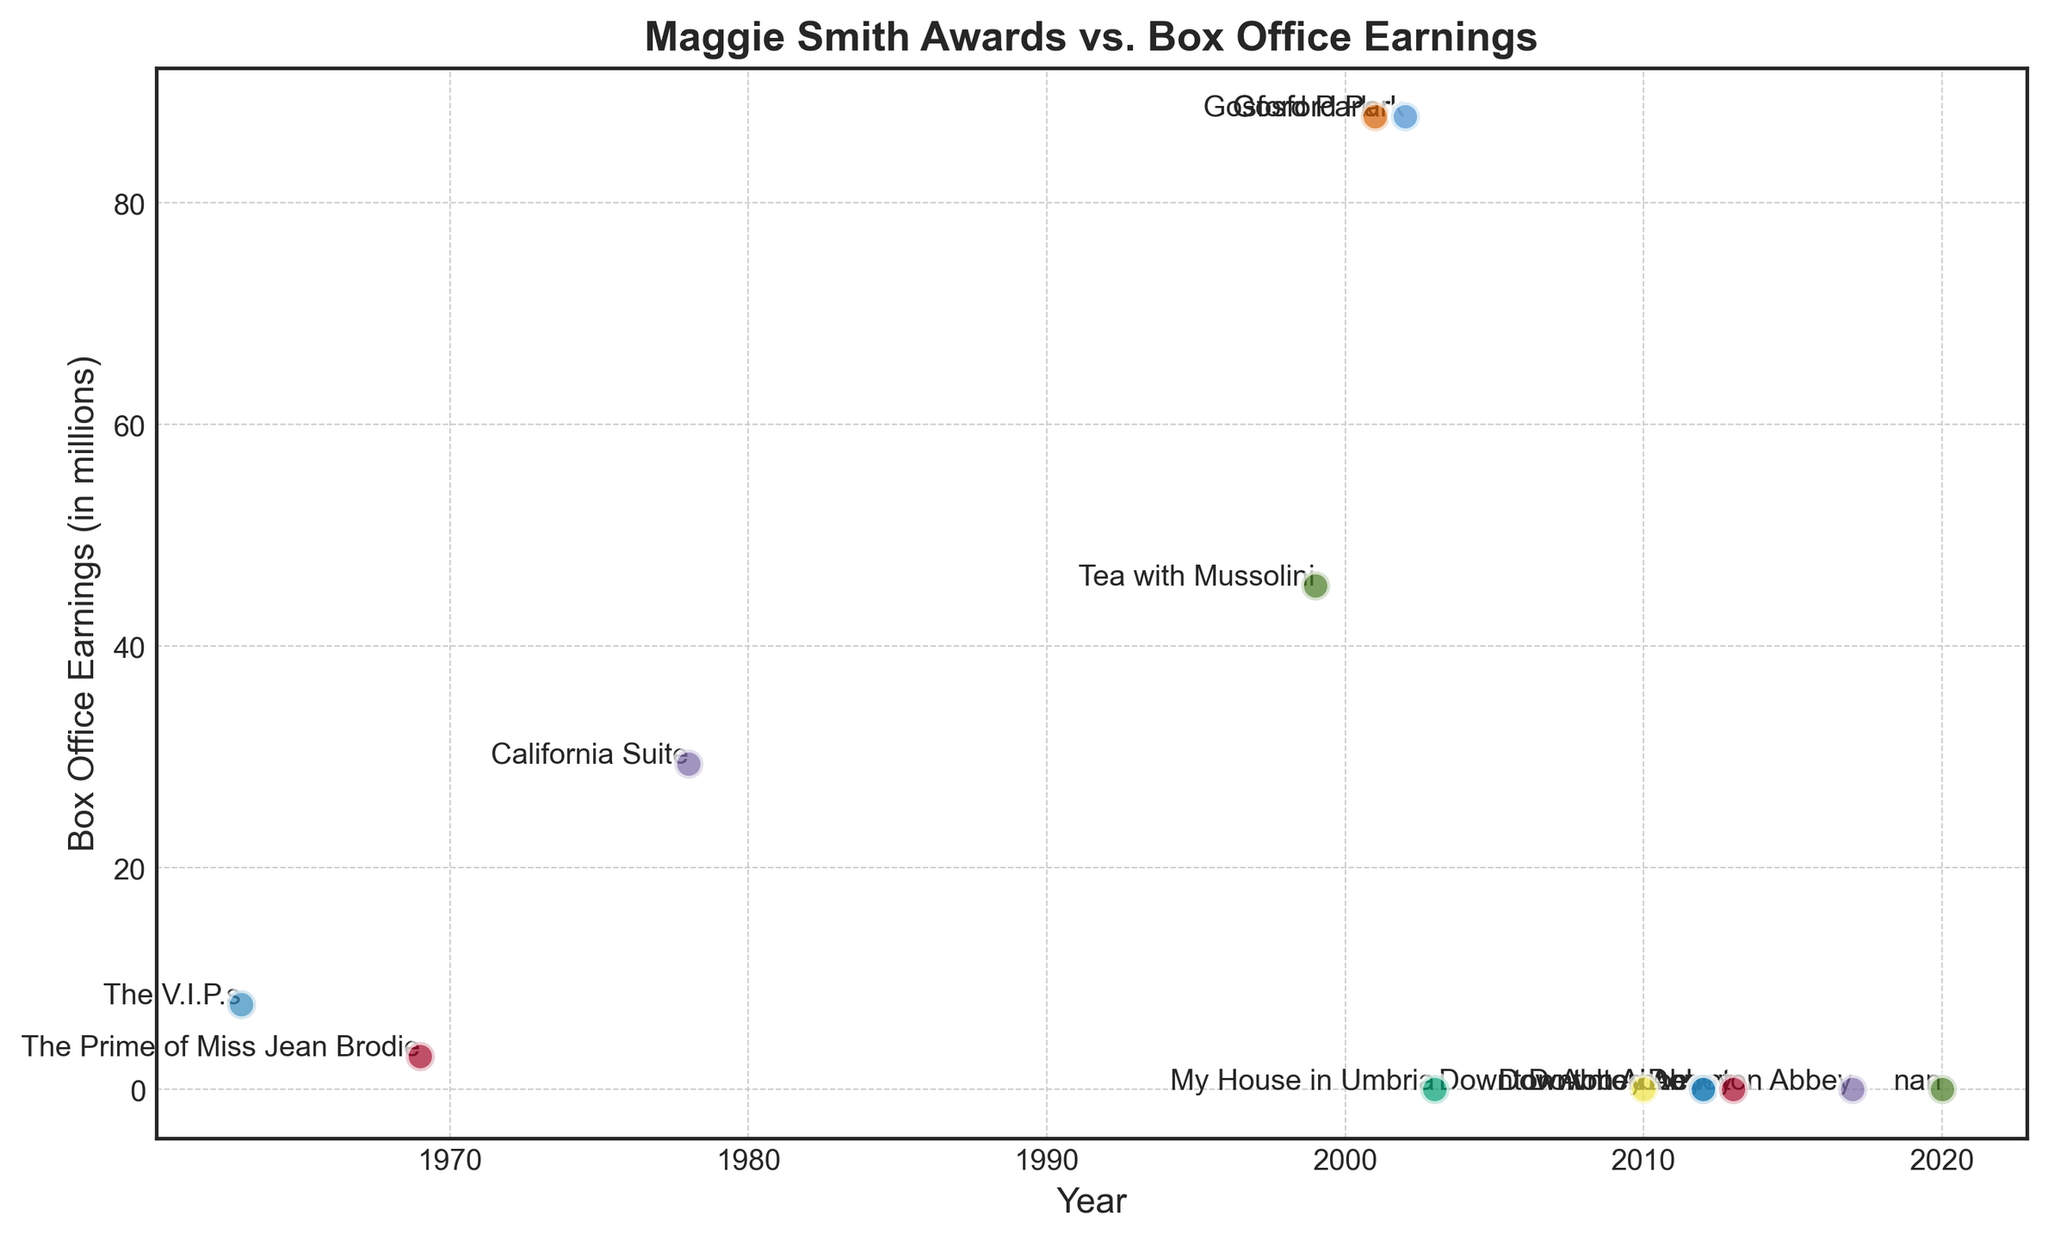What is the highest Box Office Earnings shown in the scatter plot, and which title does it correspond to? The scatter plot shows several data points with different box office earnings. The highest earning is 87.8 million, associated with the title "Gosford Park".
Answer: 87.8 million, "Gosford Park" How many awards did "Gosford Park" win, and what were the box office earnings? By counting the number of points labeled "Gosford Park" on the scatter plot, you can determine it won three awards, all associated with box office earnings of 87.8 million.
Answer: Three awards, 87.8 million Compare the box office earnings of "Tea with Mussolini" and "California Suite". Which one earned more? By examining the scatter plot, we see that "Tea with Mussolini" earned 45.5 million, while "California Suite" earned 29.4 million. Therefore, "Tea with Mussolini" earned more.
Answer: "Tea with Mussolini" What is the average box office earnings for the titles that earned any amount (non-zero earnings)? To find this, sum up the earnings for all titles that earned money (7.7 + 3.0 + 29.4 + 45.5 + 87.8) and divide by the number of such titles (5), which equals (173.4 / 5) = 34.68 million.
Answer: 34.68 million Which titles have zero box office earnings, and how many are there? Points on the scatter plot with zero earnings will indicate the titles with zero earnings. By counting, we find titles "My House in Umbria", "Downton Abbey" (five times), and "N/A" come to a total of seven.
Answer: Seven titles Which year saw the highest number of awards won by Maggie Smith, and what is the title associated with that year? By examining the years on the scatter plot and the corresponding titles, it is evident that the year 2012 has the most awards (three) associated with "Downton Abbey".
Answer: 2012, "Downton Abbey" What is the difference in box office earnings between "The Prime of Miss Jean Brodie" and "The V.I.P.s"? Subtract the box office earnings of "The Prime of Miss Jean Brodie" (3.0 million) from "The V.I.P.s" (7.7 million), resulting in a difference of (7.7 - 3.0 = 4.7 million).
Answer: 4.7 million If the box office earnings for all years are combined, what is the total earnings? Sum the box office earnings of all titles from the scatter plot: (7.7 + 3.0 + 29.4 + 45.5 + 87.8 + 87.8 + 87.8), resulting in a total of 349 million.
Answer: 349 million 